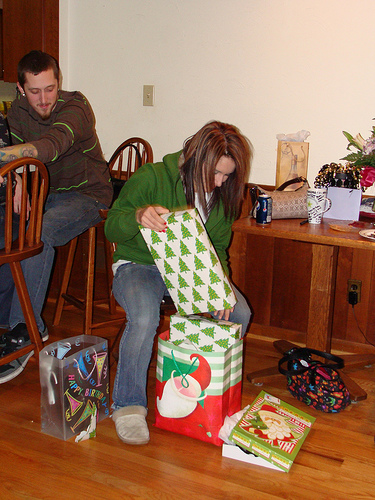<image>
Is the girl under the boy? No. The girl is not positioned under the boy. The vertical relationship between these objects is different. Is there a man in front of the woman? No. The man is not in front of the woman. The spatial positioning shows a different relationship between these objects. Where is the woman in relation to the table? Is it to the left of the table? Yes. From this viewpoint, the woman is positioned to the left side relative to the table. 